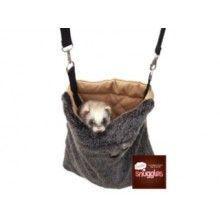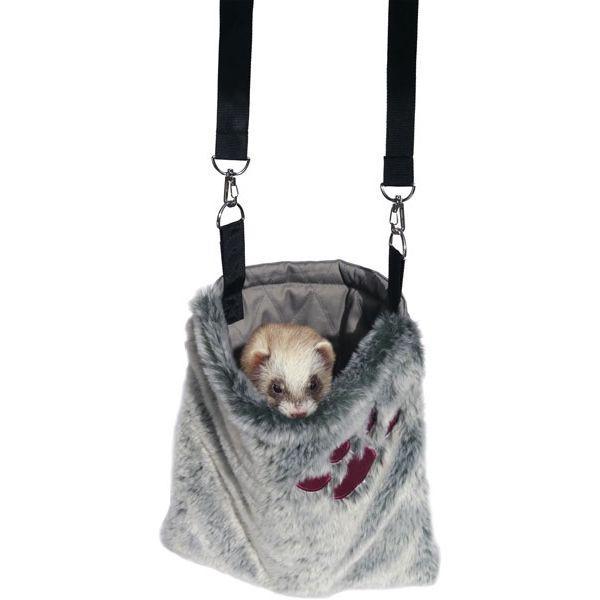The first image is the image on the left, the second image is the image on the right. For the images shown, is this caption "There is a gray pouch with a brown inner lining containing a ferret." true? Answer yes or no. Yes. 